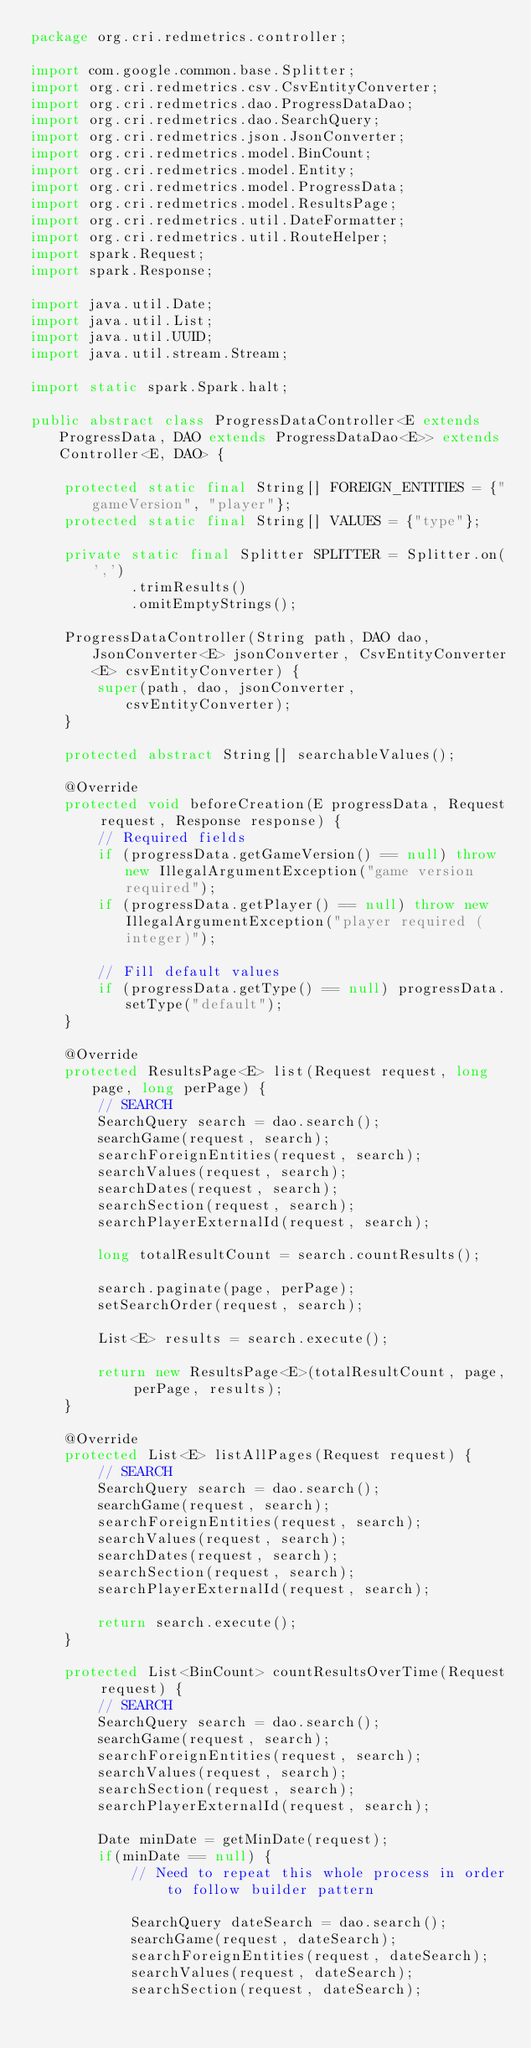<code> <loc_0><loc_0><loc_500><loc_500><_Java_>package org.cri.redmetrics.controller;

import com.google.common.base.Splitter;
import org.cri.redmetrics.csv.CsvEntityConverter;
import org.cri.redmetrics.dao.ProgressDataDao;
import org.cri.redmetrics.dao.SearchQuery;
import org.cri.redmetrics.json.JsonConverter;
import org.cri.redmetrics.model.BinCount;
import org.cri.redmetrics.model.Entity;
import org.cri.redmetrics.model.ProgressData;
import org.cri.redmetrics.model.ResultsPage;
import org.cri.redmetrics.util.DateFormatter;
import org.cri.redmetrics.util.RouteHelper;
import spark.Request;
import spark.Response;

import java.util.Date;
import java.util.List;
import java.util.UUID;
import java.util.stream.Stream;

import static spark.Spark.halt;

public abstract class ProgressDataController<E extends ProgressData, DAO extends ProgressDataDao<E>> extends Controller<E, DAO> {

    protected static final String[] FOREIGN_ENTITIES = {"gameVersion", "player"};
    protected static final String[] VALUES = {"type"};

    private static final Splitter SPLITTER = Splitter.on(',')
            .trimResults()
            .omitEmptyStrings();

    ProgressDataController(String path, DAO dao, JsonConverter<E> jsonConverter, CsvEntityConverter<E> csvEntityConverter) {
        super(path, dao, jsonConverter, csvEntityConverter);
    }

    protected abstract String[] searchableValues();

    @Override
    protected void beforeCreation(E progressData, Request request, Response response) {
        // Required fields
        if (progressData.getGameVersion() == null) throw new IllegalArgumentException("game version required");
        if (progressData.getPlayer() == null) throw new IllegalArgumentException("player required (integer)");

        // Fill default values
        if (progressData.getType() == null) progressData.setType("default");
    }

    @Override
    protected ResultsPage<E> list(Request request, long page, long perPage) {
        // SEARCH
        SearchQuery search = dao.search();
        searchGame(request, search);
        searchForeignEntities(request, search);
        searchValues(request, search);
        searchDates(request, search);
        searchSection(request, search);
        searchPlayerExternalId(request, search);

        long totalResultCount = search.countResults();

        search.paginate(page, perPage);
        setSearchOrder(request, search);

        List<E> results = search.execute();

        return new ResultsPage<E>(totalResultCount, page, perPage, results);
    }

    @Override
    protected List<E> listAllPages(Request request) {
        // SEARCH
        SearchQuery search = dao.search();
        searchGame(request, search);
        searchForeignEntities(request, search);
        searchValues(request, search);
        searchDates(request, search);
        searchSection(request, search);
        searchPlayerExternalId(request, search);

        return search.execute();
    }

    protected List<BinCount> countResultsOverTime(Request request) {
        // SEARCH
        SearchQuery search = dao.search();
        searchGame(request, search);
        searchForeignEntities(request, search);
        searchValues(request, search);
        searchSection(request, search);
        searchPlayerExternalId(request, search);

        Date minDate = getMinDate(request);
        if(minDate == null) {
            // Need to repeat this whole process in order to follow builder pattern

            SearchQuery dateSearch = dao.search();
            searchGame(request, dateSearch);
            searchForeignEntities(request, dateSearch);
            searchValues(request, dateSearch);
            searchSection(request, dateSearch);</code> 